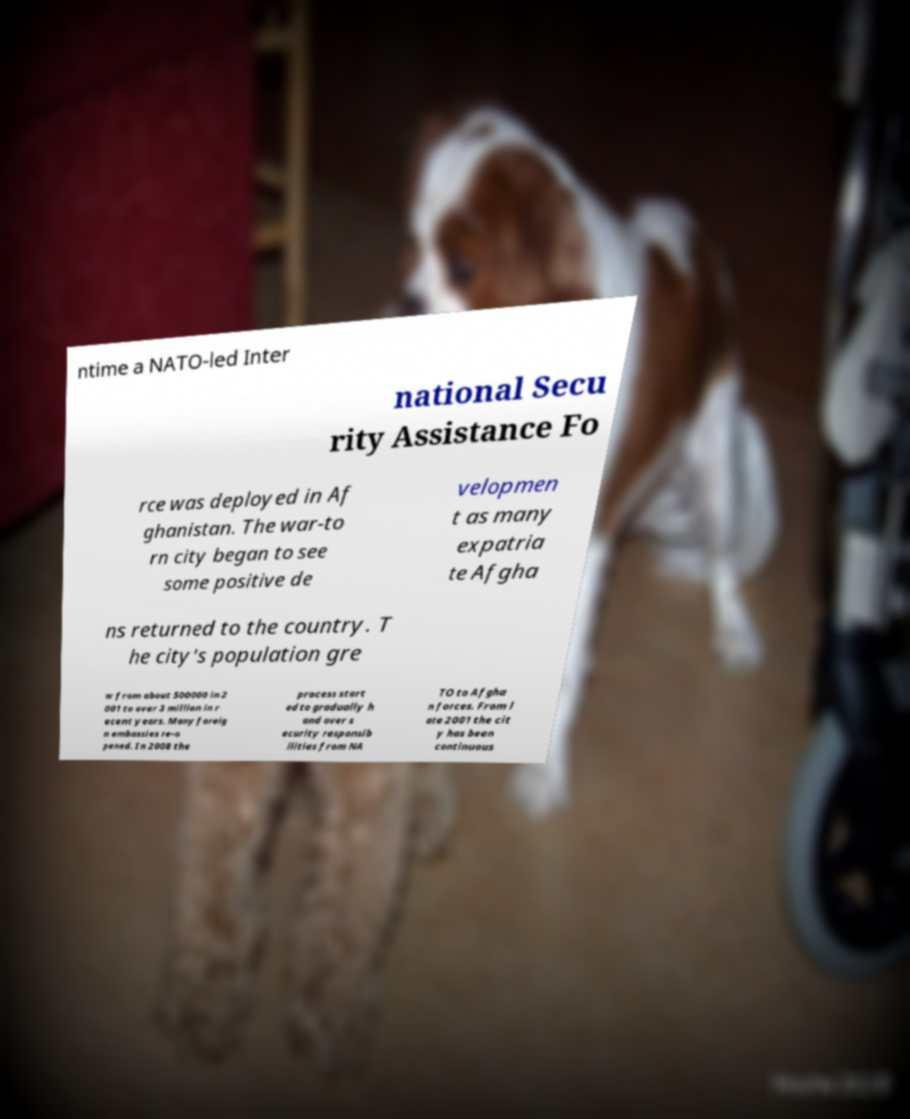There's text embedded in this image that I need extracted. Can you transcribe it verbatim? ntime a NATO-led Inter national Secu rity Assistance Fo rce was deployed in Af ghanistan. The war-to rn city began to see some positive de velopmen t as many expatria te Afgha ns returned to the country. T he city's population gre w from about 500000 in 2 001 to over 3 million in r ecent years. Many foreig n embassies re-o pened. In 2008 the process start ed to gradually h and over s ecurity responsib ilities from NA TO to Afgha n forces. From l ate 2001 the cit y has been continuous 